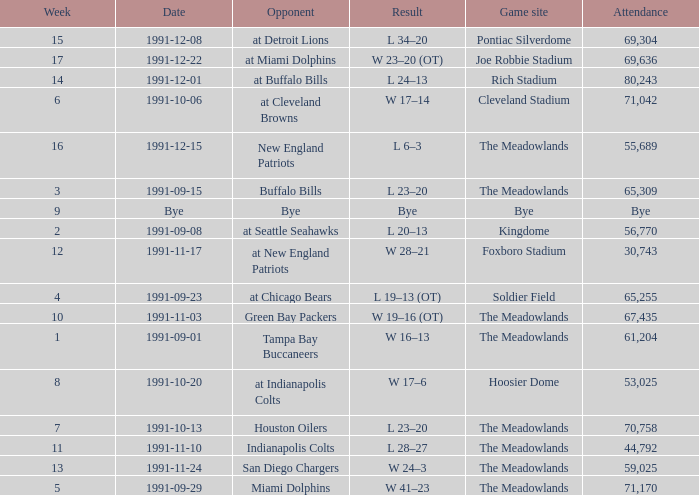Which Opponent was played on 1991-10-13? Houston Oilers. 